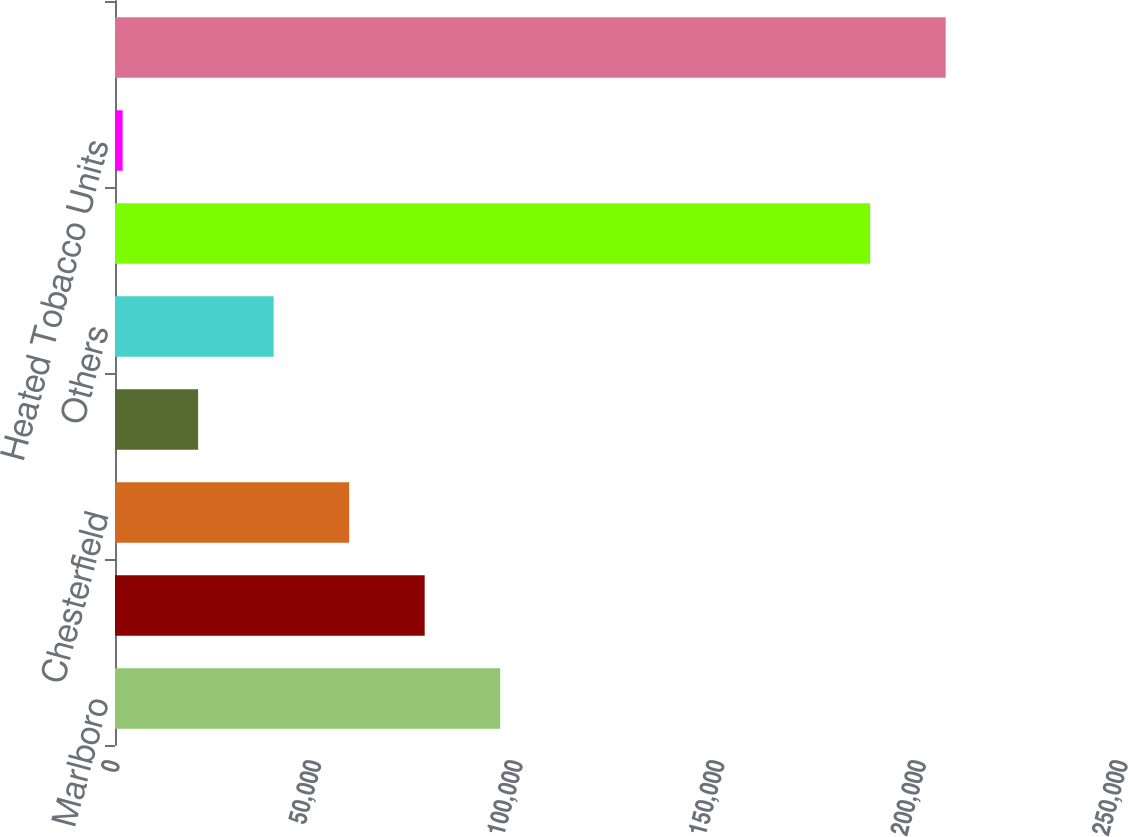<chart> <loc_0><loc_0><loc_500><loc_500><bar_chart><fcel>Marlboro<fcel>L&M<fcel>Chesterfield<fcel>Philip Morris<fcel>Others<fcel>Total Cigarettes<fcel>Heated Tobacco Units<fcel>Total European Union<nl><fcel>95535.5<fcel>76806.2<fcel>58076.9<fcel>20618.3<fcel>39347.6<fcel>187293<fcel>1889<fcel>206022<nl></chart> 